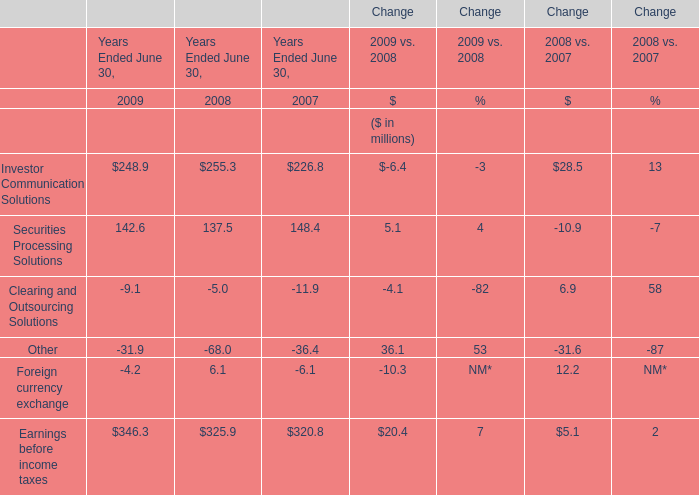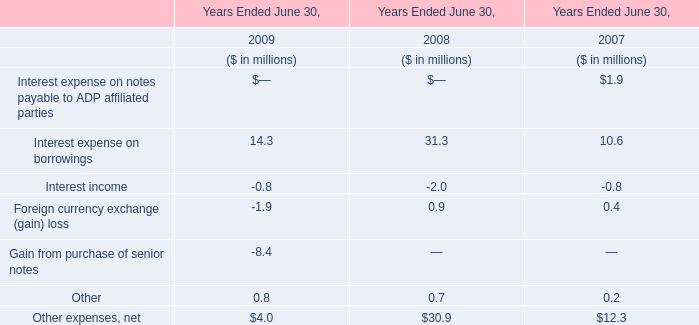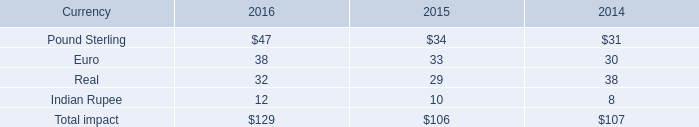What's the total amount of elements without those elements smaller than 200, in 2009? (in million) 
Computations: (248.9 + 346.3)
Answer: 595.2. 